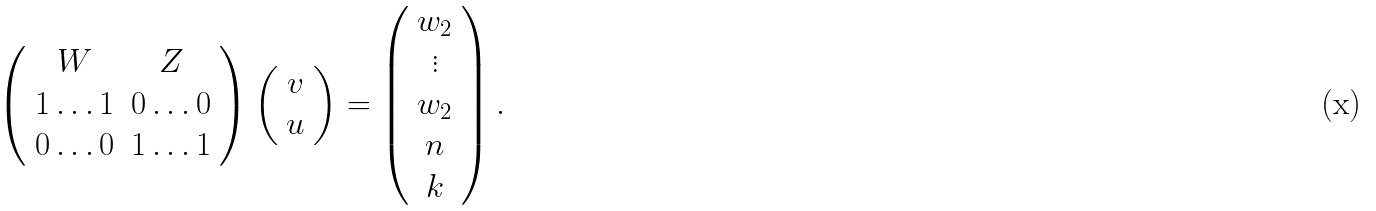Convert formula to latex. <formula><loc_0><loc_0><loc_500><loc_500>\left ( \begin{array} { c c } W & Z \\ 1 \dots 1 & 0 \dots 0 \\ 0 \dots 0 & 1 \dots 1 \\ \end{array} \right ) \left ( \begin{array} { c } v \\ u \end{array} \right ) = \left ( \begin{array} { c } w _ { 2 } \\ \vdots \\ w _ { 2 } \\ n \\ k \end{array} \right ) .</formula> 